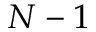<formula> <loc_0><loc_0><loc_500><loc_500>N - 1</formula> 